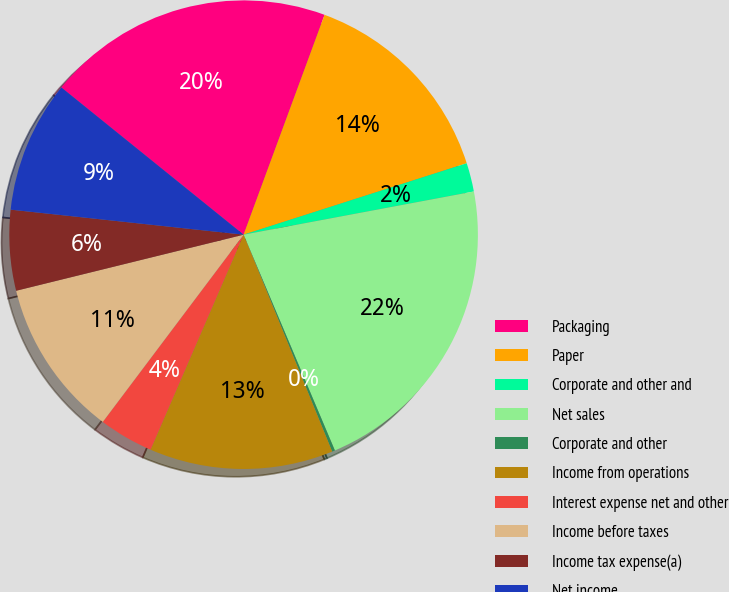<chart> <loc_0><loc_0><loc_500><loc_500><pie_chart><fcel>Packaging<fcel>Paper<fcel>Corporate and other and<fcel>Net sales<fcel>Corporate and other<fcel>Income from operations<fcel>Interest expense net and other<fcel>Income before taxes<fcel>Income tax expense(a)<fcel>Net income<nl><fcel>19.8%<fcel>14.45%<fcel>1.98%<fcel>21.58%<fcel>0.2%<fcel>12.67%<fcel>3.76%<fcel>10.89%<fcel>5.55%<fcel>9.11%<nl></chart> 